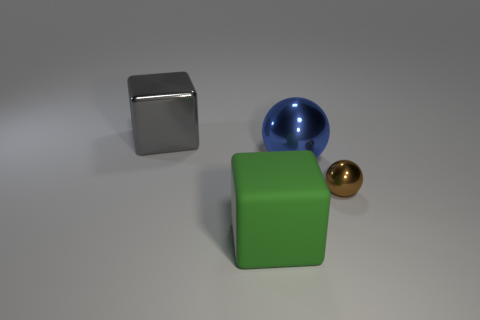Add 3 tiny gray metal objects. How many objects exist? 7 Add 2 tiny shiny things. How many tiny shiny things are left? 3 Add 3 big green objects. How many big green objects exist? 4 Subtract 1 blue balls. How many objects are left? 3 Subtract all big blue metal balls. Subtract all big metal balls. How many objects are left? 2 